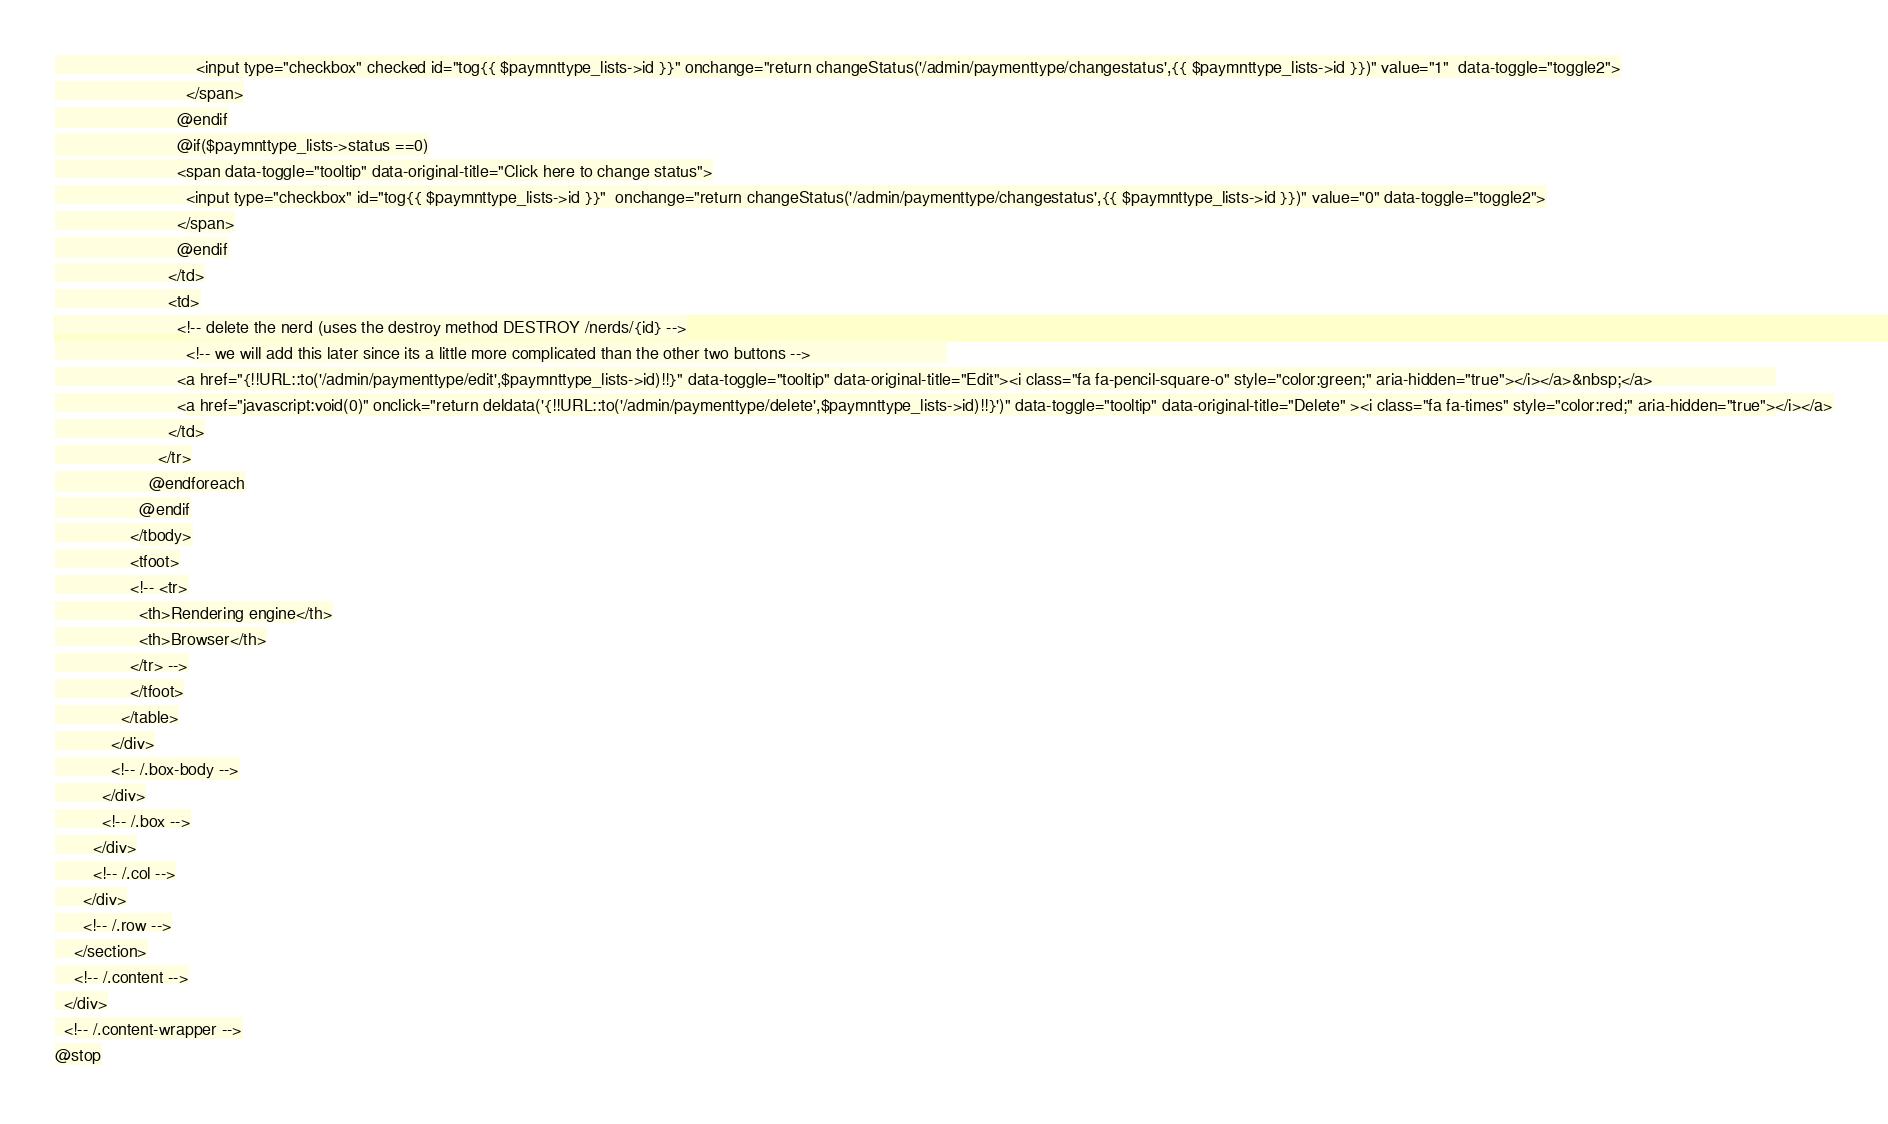Convert code to text. <code><loc_0><loc_0><loc_500><loc_500><_PHP_>                              <input type="checkbox" checked id="tog{{ $paymnttype_lists->id }}" onchange="return changeStatus('/admin/paymenttype/changestatus',{{ $paymnttype_lists->id }})" value="1"  data-toggle="toggle2">
                            </span>
                          @endif
                          @if($paymnttype_lists->status ==0)
                          <span data-toggle="tooltip" data-original-title="Click here to change status">
                            <input type="checkbox" id="tog{{ $paymnttype_lists->id }}"  onchange="return changeStatus('/admin/paymenttype/changestatus',{{ $paymnttype_lists->id }})" value="0" data-toggle="toggle2">
                          </span>
                          @endif
                        </td>
                        <td>
                          <!-- delete the nerd (uses the destroy method DESTROY /nerds/{id} -->
                            <!-- we will add this later since its a little more complicated than the other two buttons -->                             
                          <a href="{!!URL::to('/admin/paymenttype/edit',$paymnttype_lists->id)!!}" data-toggle="tooltip" data-original-title="Edit"><i class="fa fa-pencil-square-o" style="color:green;" aria-hidden="true"></i></a>&nbsp;</a>                          
                          <a href="javascript:void(0)" onclick="return deldata('{!!URL::to('/admin/paymenttype/delete',$paymnttype_lists->id)!!}')" data-toggle="tooltip" data-original-title="Delete" ><i class="fa fa-times" style="color:red;" aria-hidden="true"></i></a>
                        </td>
                      </tr>
                    @endforeach
                  @endif
                </tbody>
                <tfoot>
                <!-- <tr>
                  <th>Rendering engine</th>
                  <th>Browser</th>
                </tr> -->
                </tfoot>
              </table>
            </div>
            <!-- /.box-body -->
          </div>
          <!-- /.box -->
        </div>
        <!-- /.col -->
      </div>
      <!-- /.row -->
    </section>
    <!-- /.content -->
  </div>
  <!-- /.content-wrapper -->
@stop</code> 